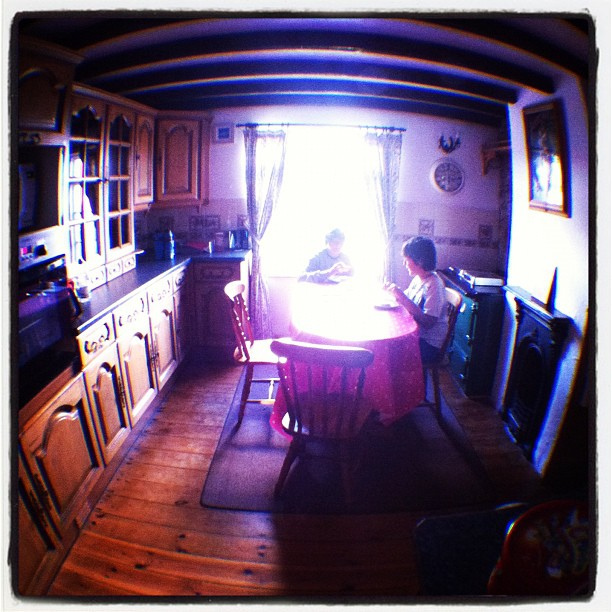Can you describe the style of the kitchen? The kitchen exhibits a cozy, country-style charm, with wooden cabinetry and flooring that give it a warm, homely feel. The decorative elements, such as the wall ornaments and the patterned tablecloth, add to the space's traditional and welcoming ambiance. 